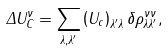<formula> <loc_0><loc_0><loc_500><loc_500>\Delta U _ { C } ^ { \nu } = \sum _ { \lambda , \lambda ^ { \prime } } \left ( U _ { c } \right ) _ { \lambda ^ { \prime } \lambda } \delta \rho ^ { \nu \nu } _ { \lambda \lambda ^ { \prime } } ,</formula> 